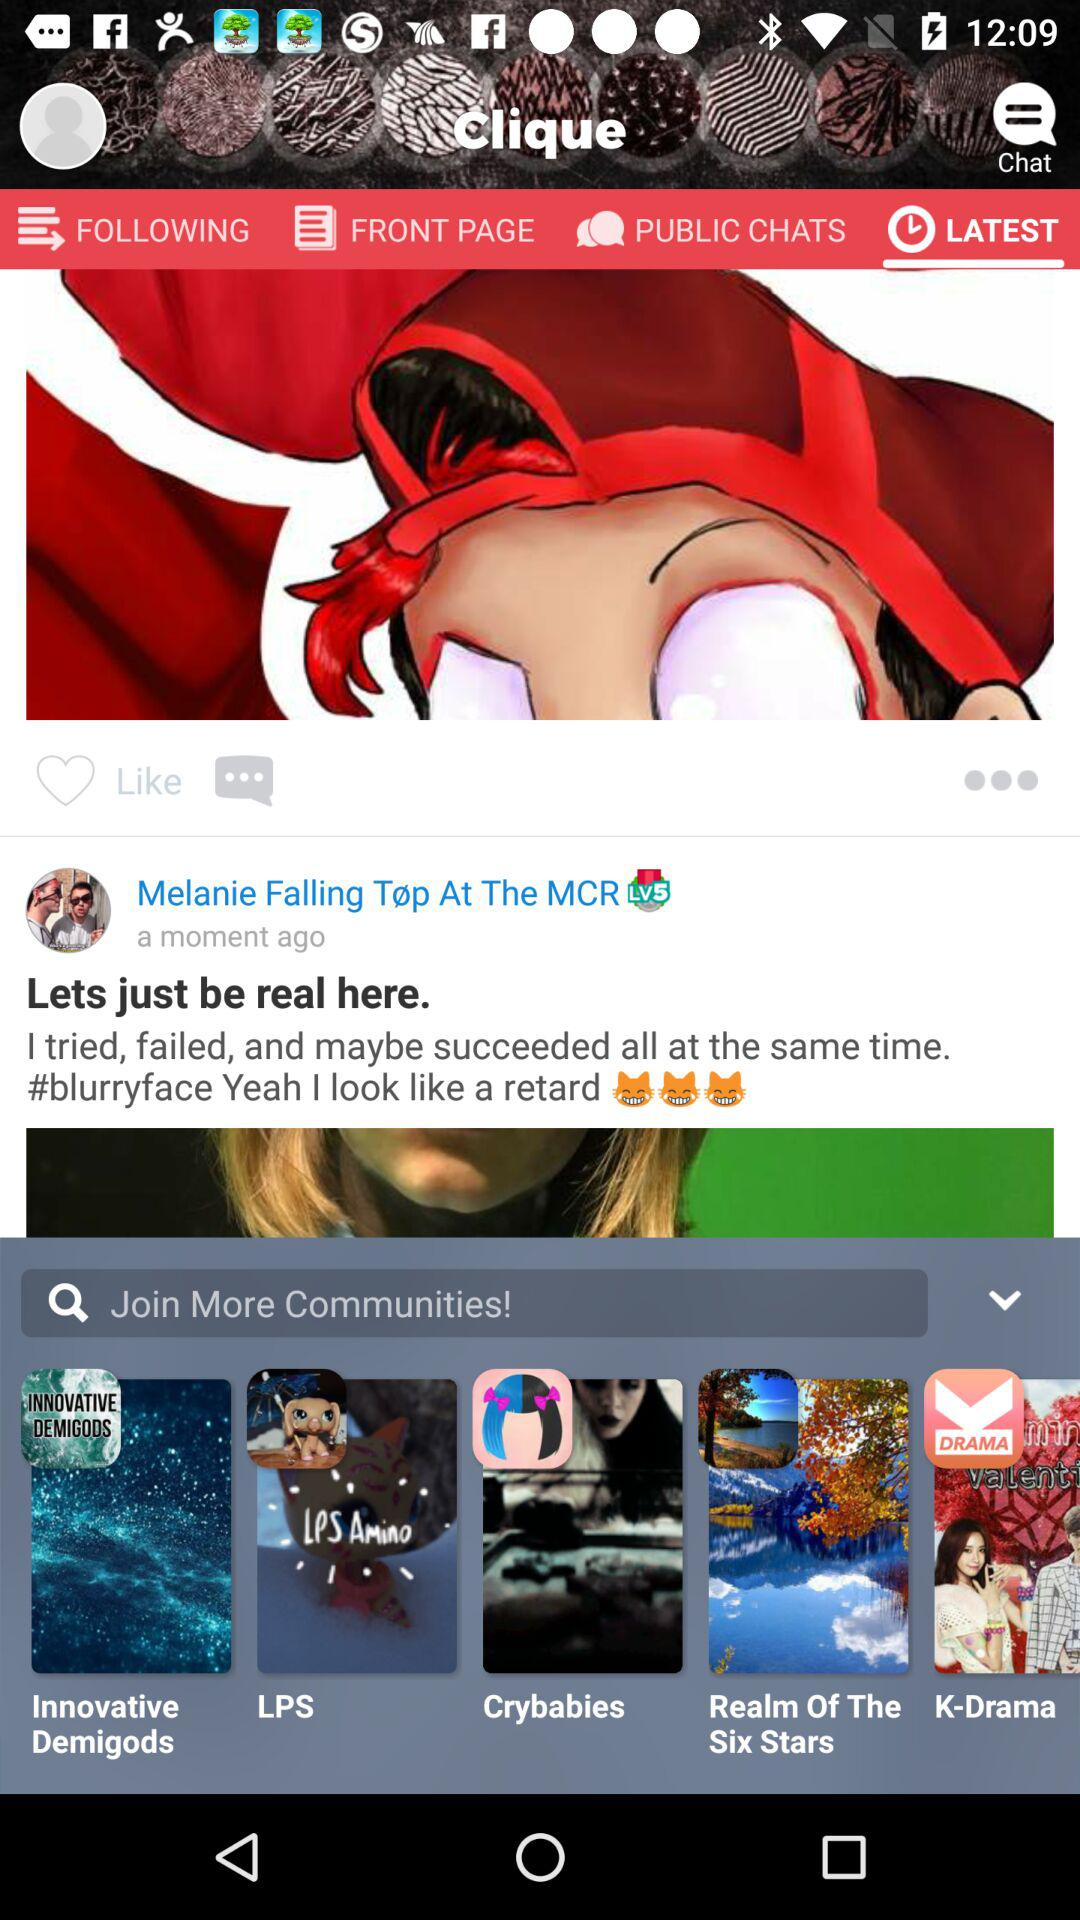What are the different communities to join? The different communities to join are "Innovative Demigods", "LPS", "Crybabies", "Realm Of The Six Stars", and "K-Drama". 